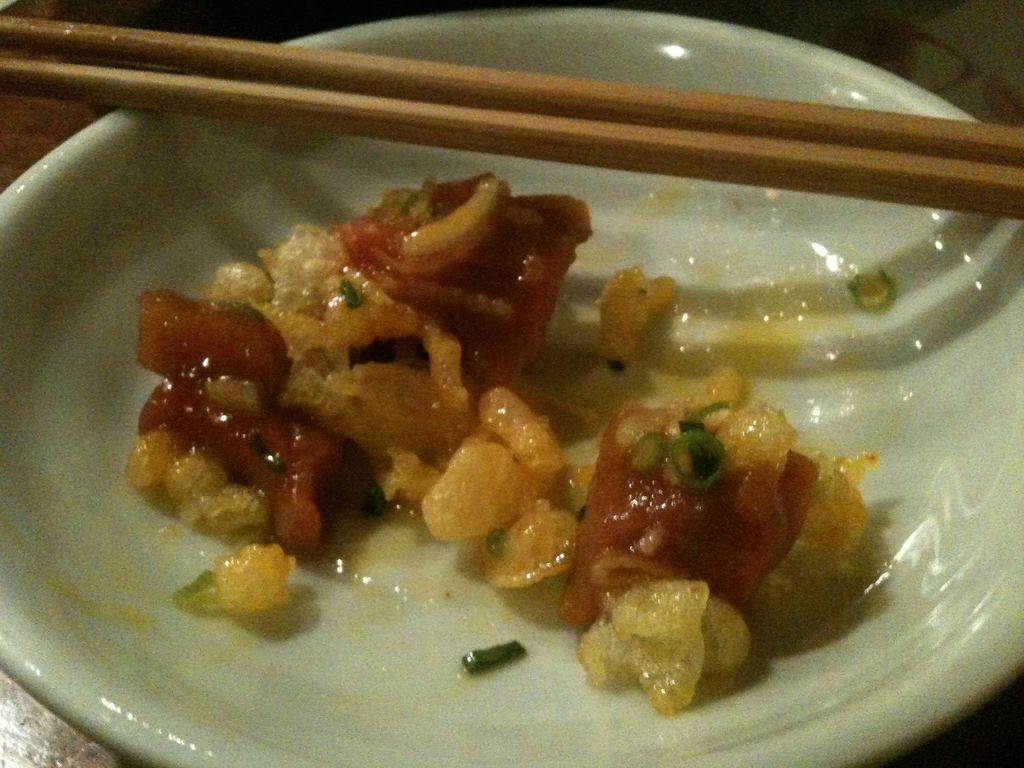What type of utensil is present in the image? There are wooden chopsticks in the image. What is on the plate that is visible in the image? There is a plate with food in the image. Where are the wooden chopsticks and plate with food located? The wooden chopsticks and plate with food are placed on a table. How does the pancake balance on the wooden chopsticks in the image? There is no pancake present in the image, so it cannot be balanced on the wooden chopsticks. 